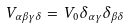<formula> <loc_0><loc_0><loc_500><loc_500>V _ { \alpha \beta \gamma \delta } = V _ { 0 } \delta _ { \alpha \gamma } \delta _ { \beta \delta }</formula> 